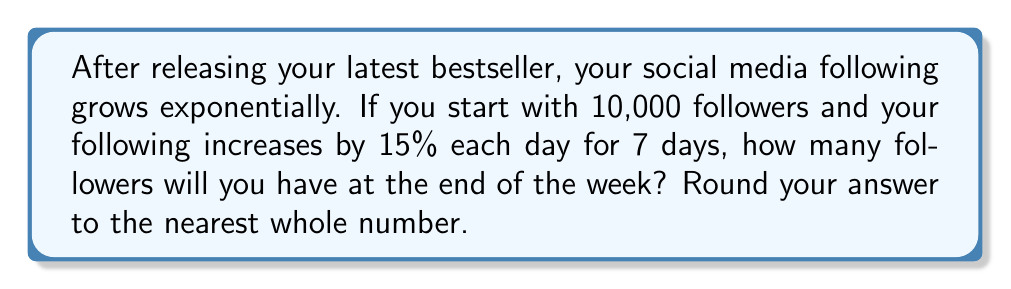Teach me how to tackle this problem. Let's approach this step-by-step:

1) We start with 10,000 followers.
2) Each day, the number of followers increases by 15%, which means it's multiplied by 1.15.
3) This happens for 7 days.

Mathematically, we can express this as:

$$ \text{Final Followers} = 10000 \times (1.15)^7 $$

Let's calculate:

$$ \begin{align}
10000 \times (1.15)^7 &= 10000 \times 2.660139
\\ &= 26601.39
\end{align} $$

Rounding to the nearest whole number:

$$ 26601.39 \approx 26601 $$
Answer: 26601 